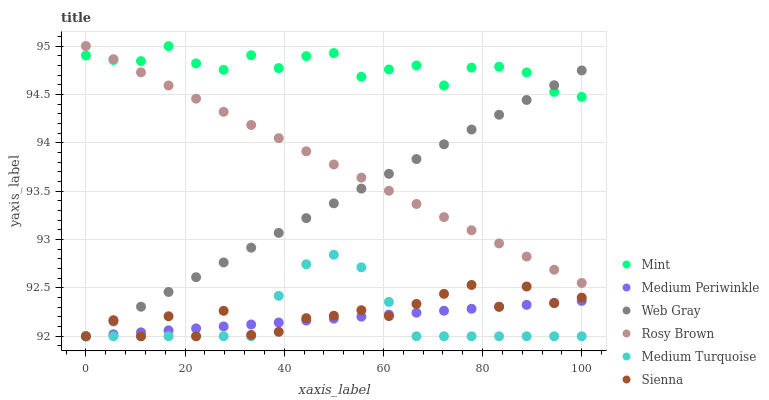Does Medium Turquoise have the minimum area under the curve?
Answer yes or no. Yes. Does Mint have the maximum area under the curve?
Answer yes or no. Yes. Does Rosy Brown have the minimum area under the curve?
Answer yes or no. No. Does Rosy Brown have the maximum area under the curve?
Answer yes or no. No. Is Web Gray the smoothest?
Answer yes or no. Yes. Is Sienna the roughest?
Answer yes or no. Yes. Is Rosy Brown the smoothest?
Answer yes or no. No. Is Rosy Brown the roughest?
Answer yes or no. No. Does Web Gray have the lowest value?
Answer yes or no. Yes. Does Rosy Brown have the lowest value?
Answer yes or no. No. Does Rosy Brown have the highest value?
Answer yes or no. Yes. Does Medium Periwinkle have the highest value?
Answer yes or no. No. Is Medium Periwinkle less than Rosy Brown?
Answer yes or no. Yes. Is Rosy Brown greater than Medium Turquoise?
Answer yes or no. Yes. Does Medium Periwinkle intersect Web Gray?
Answer yes or no. Yes. Is Medium Periwinkle less than Web Gray?
Answer yes or no. No. Is Medium Periwinkle greater than Web Gray?
Answer yes or no. No. Does Medium Periwinkle intersect Rosy Brown?
Answer yes or no. No. 